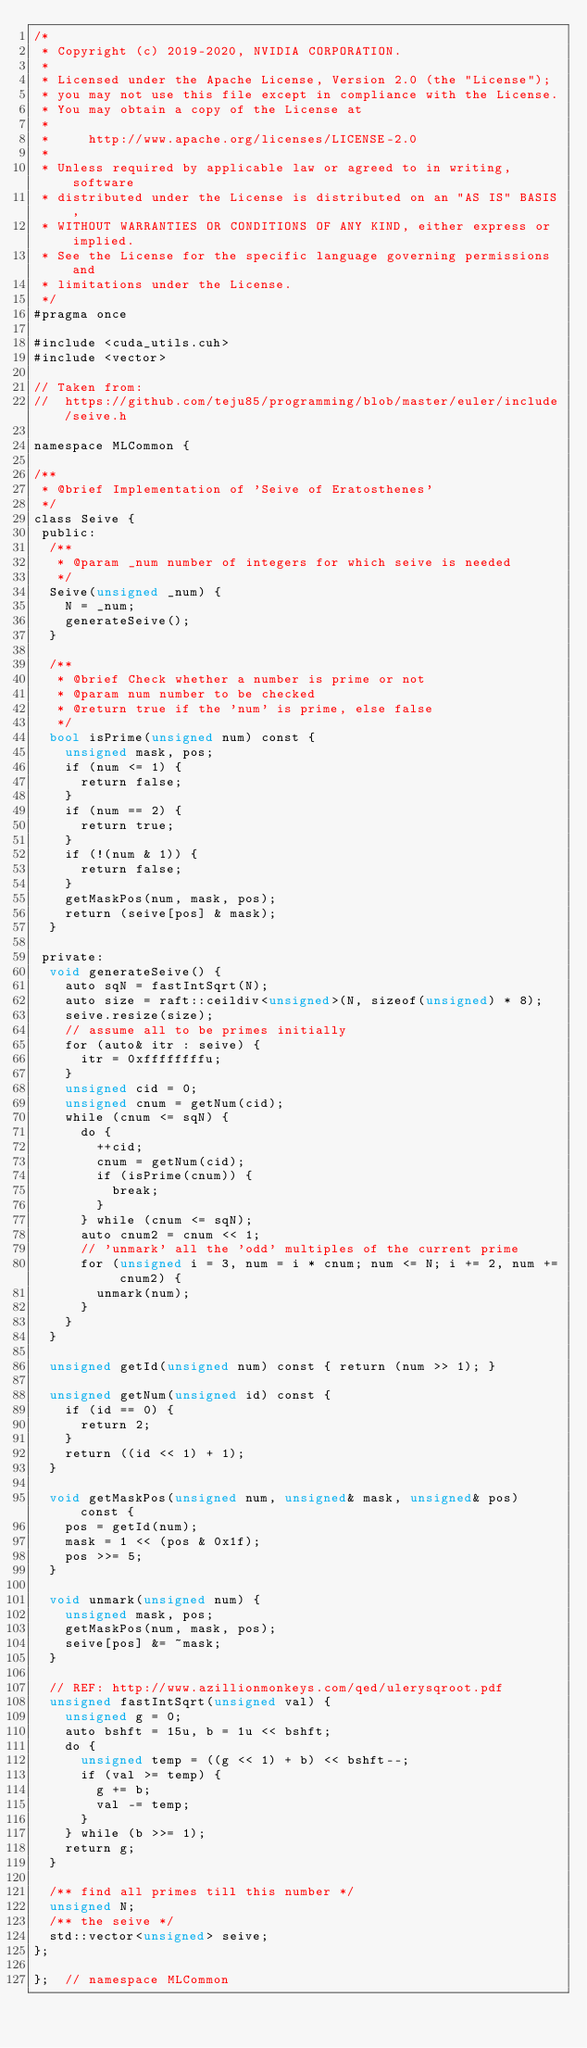Convert code to text. <code><loc_0><loc_0><loc_500><loc_500><_Cuda_>/*
 * Copyright (c) 2019-2020, NVIDIA CORPORATION.
 *
 * Licensed under the Apache License, Version 2.0 (the "License");
 * you may not use this file except in compliance with the License.
 * You may obtain a copy of the License at
 *
 *     http://www.apache.org/licenses/LICENSE-2.0
 *
 * Unless required by applicable law or agreed to in writing, software
 * distributed under the License is distributed on an "AS IS" BASIS,
 * WITHOUT WARRANTIES OR CONDITIONS OF ANY KIND, either express or implied.
 * See the License for the specific language governing permissions and
 * limitations under the License.
 */
#pragma once

#include <cuda_utils.cuh>
#include <vector>

// Taken from:
//  https://github.com/teju85/programming/blob/master/euler/include/seive.h

namespace MLCommon {

/**
 * @brief Implementation of 'Seive of Eratosthenes'
 */
class Seive {
 public:
  /**
   * @param _num number of integers for which seive is needed
   */
  Seive(unsigned _num) {
    N = _num;
    generateSeive();
  }

  /**
   * @brief Check whether a number is prime or not
   * @param num number to be checked
   * @return true if the 'num' is prime, else false
   */
  bool isPrime(unsigned num) const {
    unsigned mask, pos;
    if (num <= 1) {
      return false;
    }
    if (num == 2) {
      return true;
    }
    if (!(num & 1)) {
      return false;
    }
    getMaskPos(num, mask, pos);
    return (seive[pos] & mask);
  }

 private:
  void generateSeive() {
    auto sqN = fastIntSqrt(N);
    auto size = raft::ceildiv<unsigned>(N, sizeof(unsigned) * 8);
    seive.resize(size);
    // assume all to be primes initially
    for (auto& itr : seive) {
      itr = 0xffffffffu;
    }
    unsigned cid = 0;
    unsigned cnum = getNum(cid);
    while (cnum <= sqN) {
      do {
        ++cid;
        cnum = getNum(cid);
        if (isPrime(cnum)) {
          break;
        }
      } while (cnum <= sqN);
      auto cnum2 = cnum << 1;
      // 'unmark' all the 'odd' multiples of the current prime
      for (unsigned i = 3, num = i * cnum; num <= N; i += 2, num += cnum2) {
        unmark(num);
      }
    }
  }

  unsigned getId(unsigned num) const { return (num >> 1); }

  unsigned getNum(unsigned id) const {
    if (id == 0) {
      return 2;
    }
    return ((id << 1) + 1);
  }

  void getMaskPos(unsigned num, unsigned& mask, unsigned& pos) const {
    pos = getId(num);
    mask = 1 << (pos & 0x1f);
    pos >>= 5;
  }

  void unmark(unsigned num) {
    unsigned mask, pos;
    getMaskPos(num, mask, pos);
    seive[pos] &= ~mask;
  }

  // REF: http://www.azillionmonkeys.com/qed/ulerysqroot.pdf
  unsigned fastIntSqrt(unsigned val) {
    unsigned g = 0;
    auto bshft = 15u, b = 1u << bshft;
    do {
      unsigned temp = ((g << 1) + b) << bshft--;
      if (val >= temp) {
        g += b;
        val -= temp;
      }
    } while (b >>= 1);
    return g;
  }

  /** find all primes till this number */
  unsigned N;
  /** the seive */
  std::vector<unsigned> seive;
};

};  // namespace MLCommon
</code> 